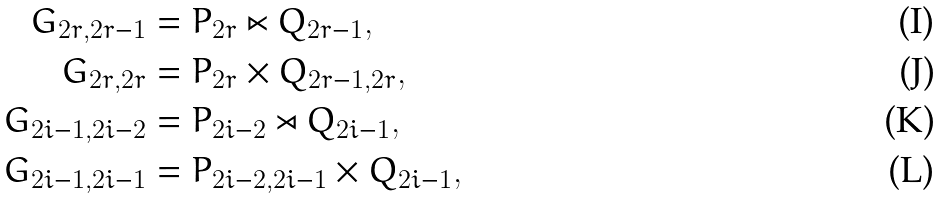<formula> <loc_0><loc_0><loc_500><loc_500>G _ { 2 r , 2 r - 1 } & = P _ { 2 r } \ltimes Q _ { 2 r - 1 } , \\ G _ { 2 r , 2 r } & = P _ { 2 r } \times Q _ { 2 r - 1 , 2 r } , \\ G _ { 2 i - 1 , 2 i - 2 } & = P _ { 2 i - 2 } \rtimes Q _ { 2 i - 1 } , \\ G _ { 2 i - 1 , 2 i - 1 } & = P _ { 2 i - 2 , 2 i - 1 } \times Q _ { 2 i - 1 } ,</formula> 